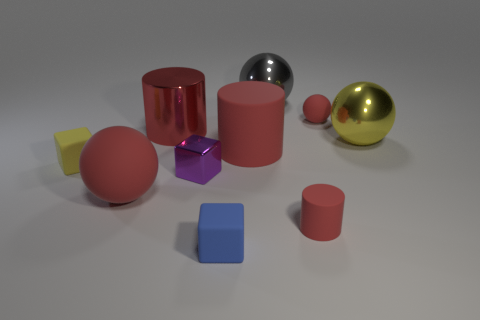There is a small sphere that is the same color as the tiny cylinder; what is it made of?
Offer a terse response. Rubber. What number of matte cylinders have the same color as the tiny sphere?
Offer a terse response. 2. How many things are either large things that are behind the big red shiny cylinder or red rubber cubes?
Keep it short and to the point. 1. There is a big cylinder that is made of the same material as the tiny red ball; what color is it?
Your response must be concise. Red. Are there any blue matte cylinders of the same size as the red metallic cylinder?
Your answer should be very brief. No. What number of things are either metallic balls right of the gray shiny thing or rubber balls to the right of the red shiny cylinder?
Provide a short and direct response. 2. There is a shiny thing that is the same size as the blue matte cube; what shape is it?
Your response must be concise. Cube. Are there any other small objects that have the same shape as the tiny yellow matte thing?
Keep it short and to the point. Yes. Are there fewer red matte balls than large red balls?
Ensure brevity in your answer.  No. There is a red rubber sphere that is on the left side of the big gray metal ball; is its size the same as the red rubber ball on the right side of the gray metal thing?
Offer a very short reply. No. 